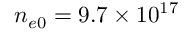Convert formula to latex. <formula><loc_0><loc_0><loc_500><loc_500>n _ { e 0 } = 9 . 7 \times 1 0 ^ { 1 7 }</formula> 